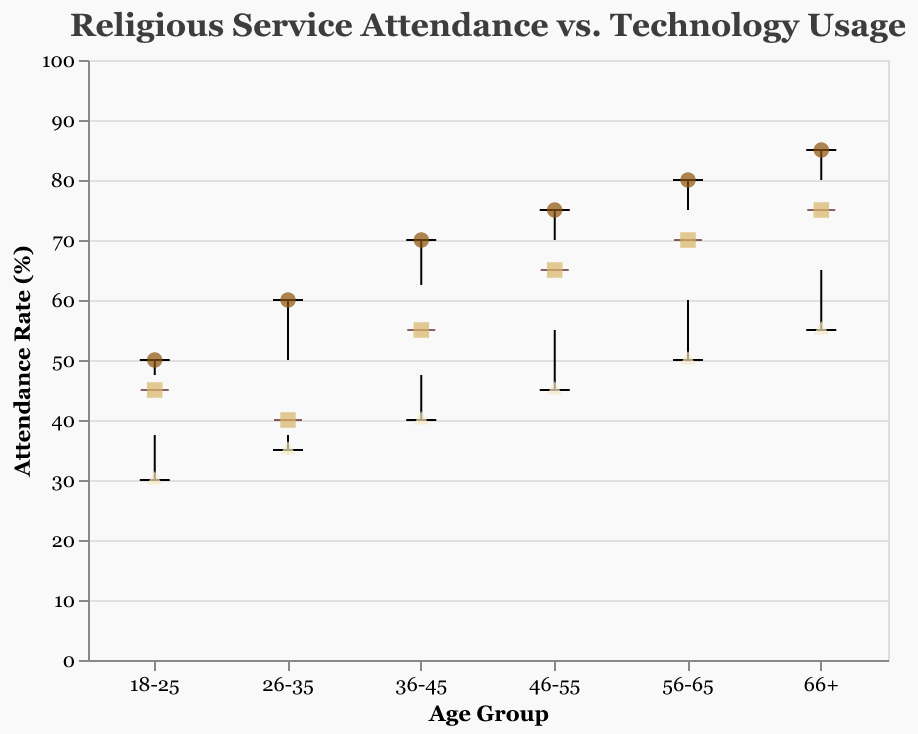What is the title of the plot? The title of the plot is at the top of the figure, which reads "Religious Service Attendance vs. Technology Usage."
Answer: Religious Service Attendance vs. Technology Usage Which age group has the lowest attendance rate overall? By examining the scatter points and boxplot data, the "18-25" age group has the lowest attendance rate, with the point at 30%.
Answer: 18-25 How does attendance rate change with age in the "Low" technology usage group? Looking at the data points for the "Low" technology usage group, attendance rate increases with age: 18-25 (50%), 26-35 (60%), 36-45 (70%), 46-55 (75%), 56-65 (80%), 66+ (85%).
Answer: Increases What is the relationship between technology usage and attendance rate in the 46-55 age group? For the 46-55 age group, the attendance rates for different technology usage levels are: Low (75%), Medium (65%), High (45%). Thus, higher technology use corresponds with lower attendance rates in this group.
Answer: Higher tech use, lower attendance Which age group shows the highest overall attendance rate? By viewing the scatter points and the boxplots, the "66+" age group shows the highest overall attendance rate, with points reaching up to 85%.
Answer: 66+ In which age group does high technology usage seem to have the least negative impact on attendance rates? By comparing the "High" technology usage data points across age groups, 56-65 and 66+ show relatively higher attendance rates (50-55%) for high technology usage.
Answer: 66+ For the age groups 26-35 and 46-55, what is the difference in attendance rates for "Low" technology usage? The attendance rate for "Low" technology usage in 26-35 is 60%, and for 46-55 is 75%. The difference is 75% - 60% = 15%.
Answer: 15% What is the median attendance rate for the 36-45 age group? In the boxplot for the 36-45 age group, the median is represented by the line in the middle of the box. This line corresponds to 55%.
Answer: 55% Which technology usage level has the most scatter points overall? By counting the data points in each technology usage category across all age groups, "Low" technology usage seems to have the most scatter points. There are six data points, one for each age group.
Answer: Low How do attendance rates vary in the 18-25 age group based on technology usage? For the 18-25 age group, the attendance rates for different technology usage levels are: High (30%), Medium (45%), Low (50%). This shows that as technology usage decreases, attendance rates increase.
Answer: Decreases with higher tech usage 